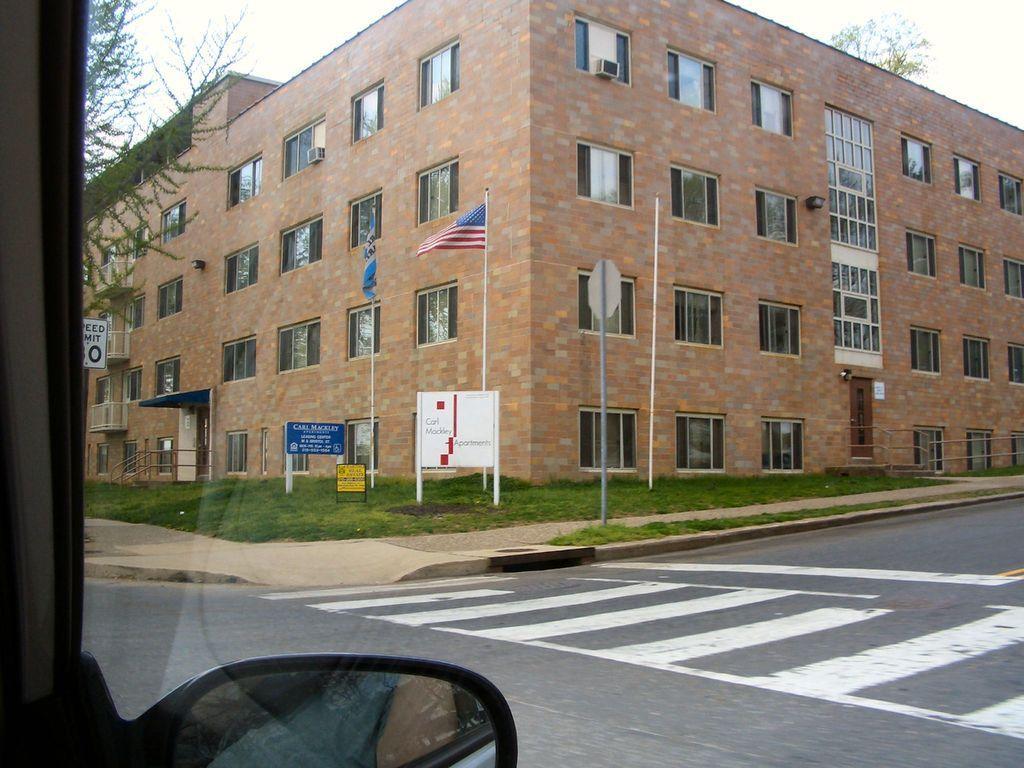Can you describe this image briefly? In this picture I can see there is a building and it has doors, windows and I can see there is a walkway and there are few poles, precaution boards and there are flagpoles and there is grass on the floor, there is a tree into left and there is a zebra crossing on the road. There is a reflection of a person in the glass of the window. The sky is clear. 